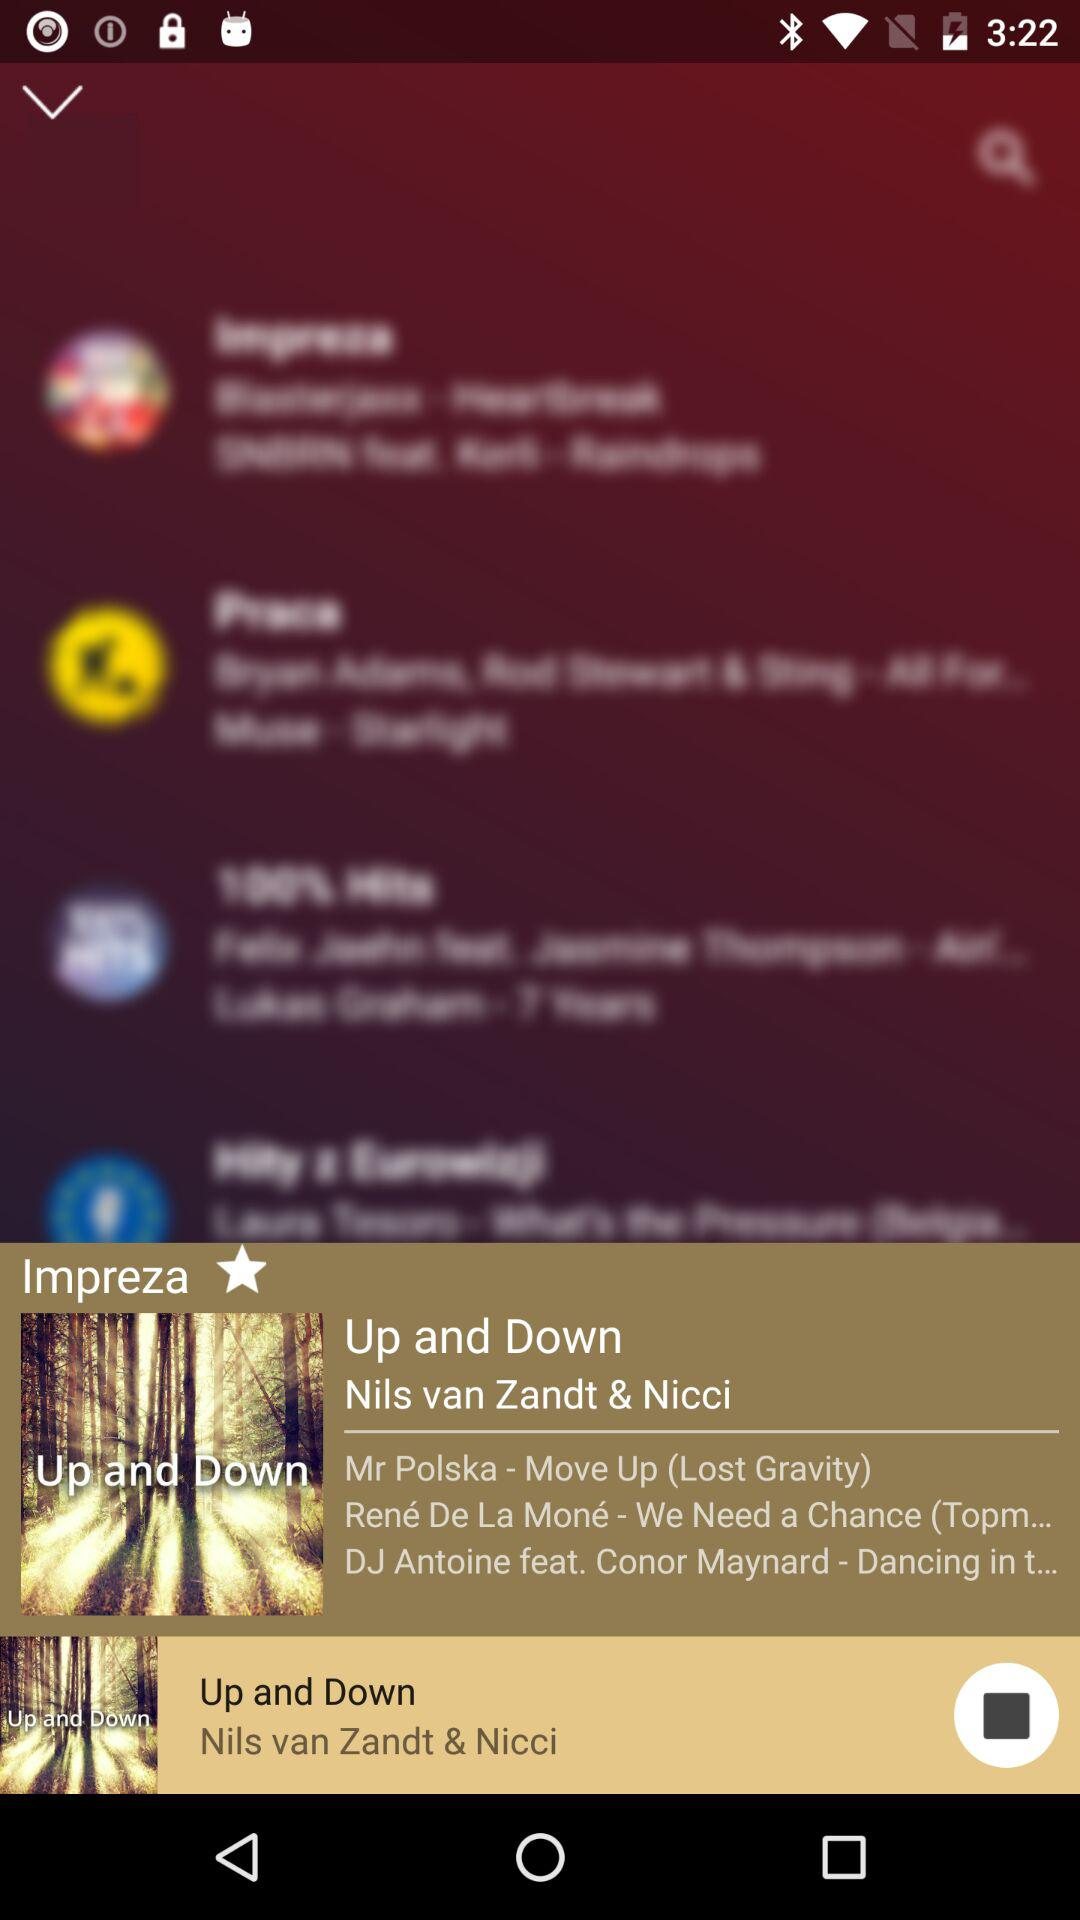What's the current playing song's name? The song's name is "Up and Down". 